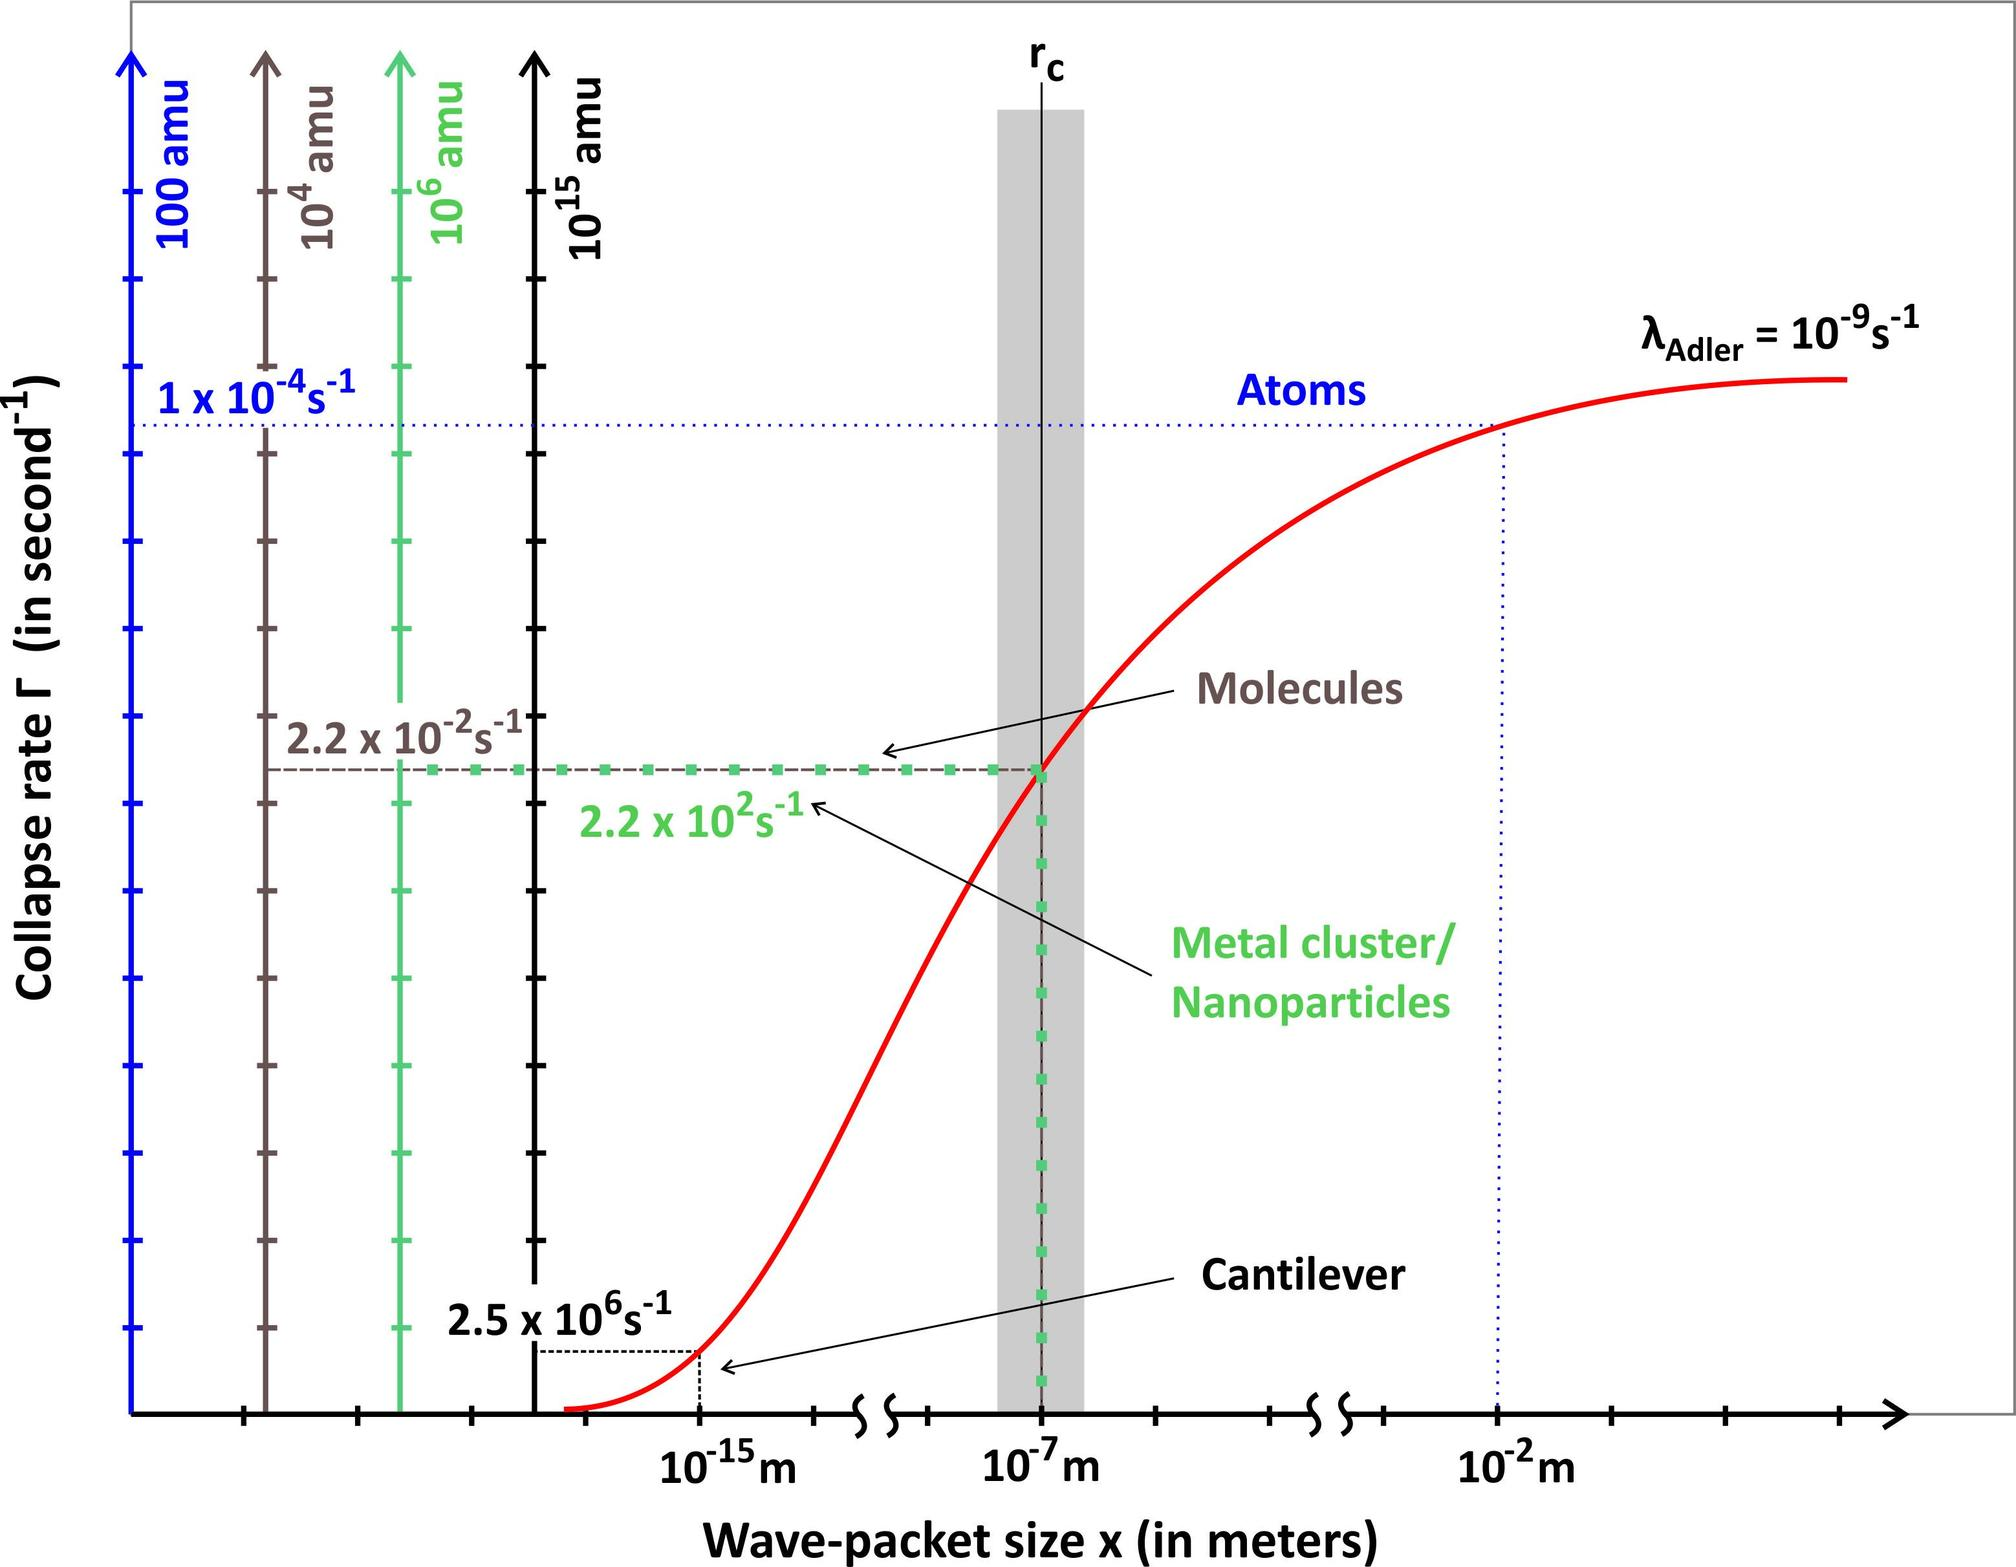What does the red curve on this graph represent, and why might it be significant? The red curve on this graph represents the boundary between different phases of matter such as atoms, molecules, and metal clusters. It illustrates how the stability of these structures changes under varying conditions. The significance of this curve lies in its ability to explain quantum mechanical phenomena such as wave-packet collapse in different materials, which is crucial for understanding material properties at the nano-scale and their practical applications in technology and medicine. 